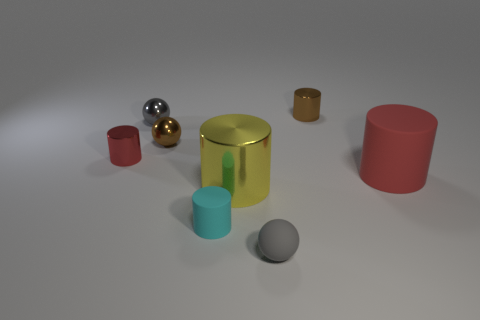Subtract all brown cylinders. How many cylinders are left? 4 Subtract all yellow blocks. How many red cylinders are left? 2 Add 1 tiny red matte balls. How many objects exist? 9 Subtract 2 cylinders. How many cylinders are left? 3 Subtract all red cylinders. How many cylinders are left? 3 Subtract all yellow balls. Subtract all yellow cubes. How many balls are left? 3 Subtract all tiny cyan matte cylinders. Subtract all red matte spheres. How many objects are left? 7 Add 3 small shiny things. How many small shiny things are left? 7 Add 1 large red rubber cylinders. How many large red rubber cylinders exist? 2 Subtract 0 cyan blocks. How many objects are left? 8 